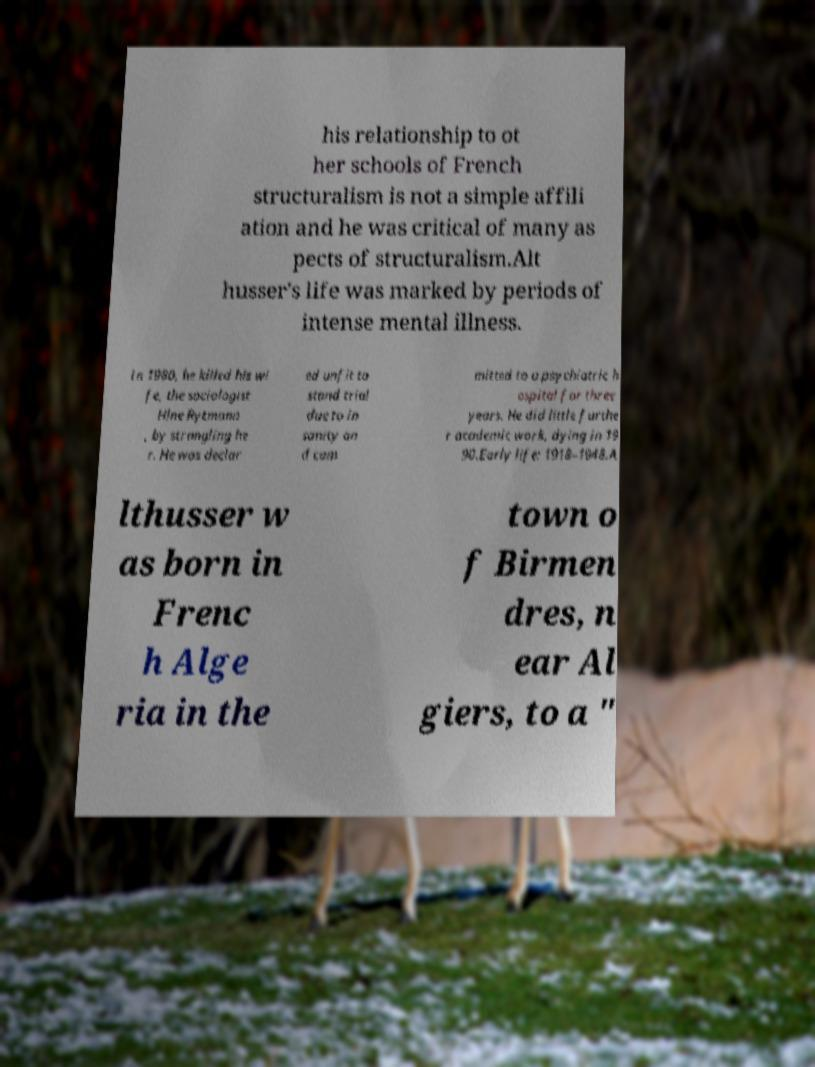Please read and relay the text visible in this image. What does it say? his relationship to ot her schools of French structuralism is not a simple affili ation and he was critical of many as pects of structuralism.Alt husser's life was marked by periods of intense mental illness. In 1980, he killed his wi fe, the sociologist Hlne Rytmann , by strangling he r. He was declar ed unfit to stand trial due to in sanity an d com mitted to a psychiatric h ospital for three years. He did little furthe r academic work, dying in 19 90.Early life: 1918–1948.A lthusser w as born in Frenc h Alge ria in the town o f Birmen dres, n ear Al giers, to a " 